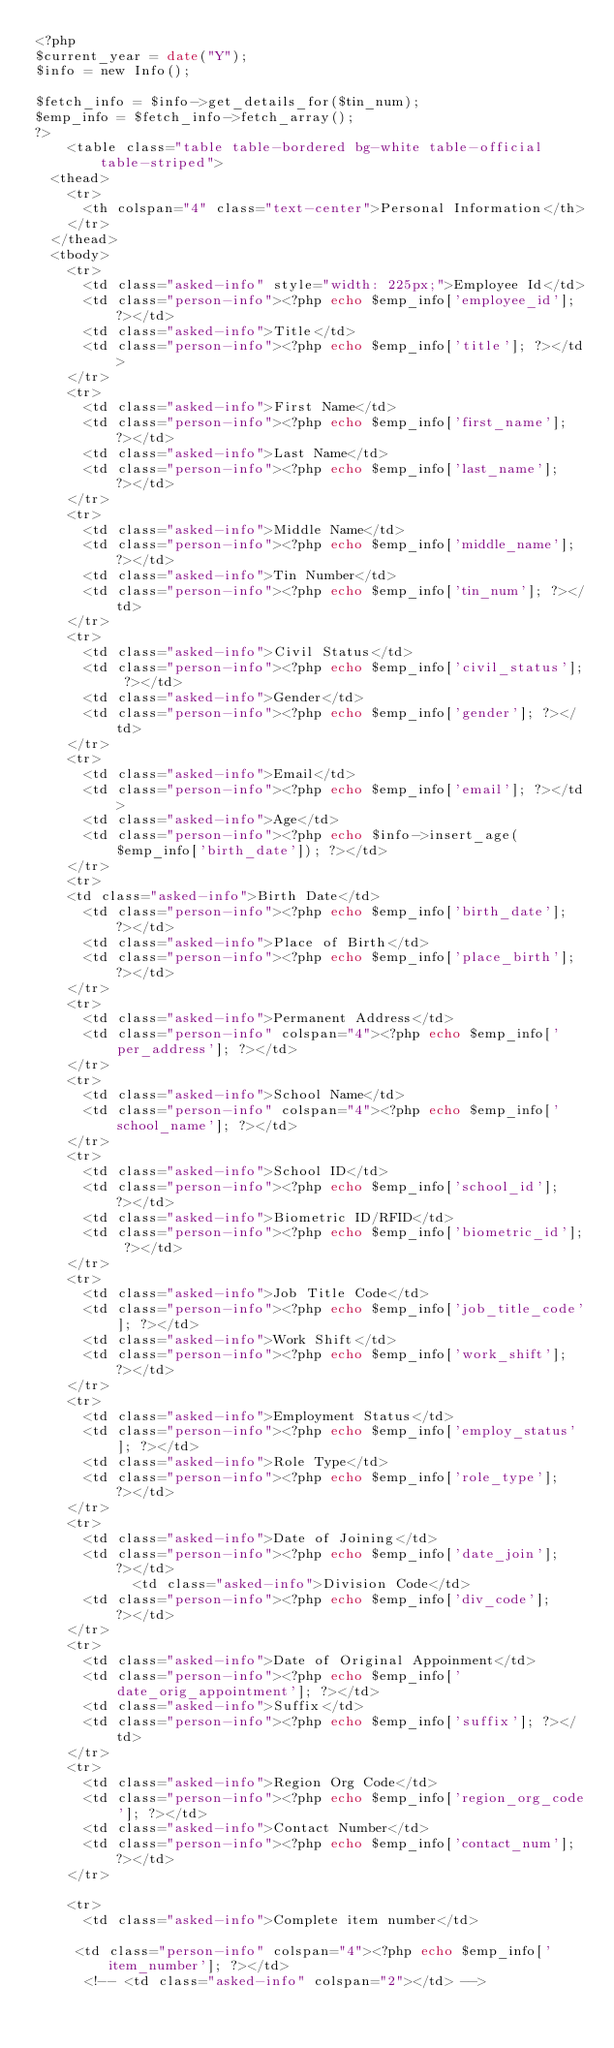<code> <loc_0><loc_0><loc_500><loc_500><_PHP_><?php
$current_year = date("Y");
$info = new Info();

$fetch_info = $info->get_details_for($tin_num);
$emp_info = $fetch_info->fetch_array();
?>
    <table class="table table-bordered bg-white table-official table-striped">
  <thead>
    <tr>
      <th colspan="4" class="text-center">Personal Information</th>
    </tr>
  </thead>
  <tbody>
    <tr>
      <td class="asked-info" style="width: 225px;">Employee Id</td>
      <td class="person-info"><?php echo $emp_info['employee_id']; ?></td>
      <td class="asked-info">Title</td>
      <td class="person-info"><?php echo $emp_info['title']; ?></td>
    </tr>
    <tr>
      <td class="asked-info">First Name</td>
      <td class="person-info"><?php echo $emp_info['first_name']; ?></td>
      <td class="asked-info">Last Name</td>
      <td class="person-info"><?php echo $emp_info['last_name']; ?></td>
    </tr>
    <tr>
      <td class="asked-info">Middle Name</td>
      <td class="person-info"><?php echo $emp_info['middle_name']; ?></td>
      <td class="asked-info">Tin Number</td>
      <td class="person-info"><?php echo $emp_info['tin_num']; ?></td>  
    </tr>
    <tr>
      <td class="asked-info">Civil Status</td>
      <td class="person-info"><?php echo $emp_info['civil_status']; ?></td>
      <td class="asked-info">Gender</td>
      <td class="person-info"><?php echo $emp_info['gender']; ?></td>
    </tr>
    <tr>  
      <td class="asked-info">Email</td>
      <td class="person-info"><?php echo $emp_info['email']; ?></td> 
      <td class="asked-info">Age</td>
      <td class="person-info"><?php echo $info->insert_age($emp_info['birth_date']); ?></td>   
    </tr>                          
    <tr>
    <td class="asked-info">Birth Date</td>
      <td class="person-info"><?php echo $emp_info['birth_date']; ?></td>
      <td class="asked-info">Place of Birth</td>
      <td class="person-info"><?php echo $emp_info['place_birth']; ?></td>   
    </tr>
    <tr>
      <td class="asked-info">Permanent Address</td>
      <td class="person-info" colspan="4"><?php echo $emp_info['per_address']; ?></td>    
    </tr>   
    <tr>
      <td class="asked-info">School Name</td>
      <td class="person-info" colspan="4"><?php echo $emp_info['school_name']; ?></td>    
    </tr>        
    <tr>
      <td class="asked-info">School ID</td>
      <td class="person-info"><?php echo $emp_info['school_id']; ?></td> 
      <td class="asked-info">Biometric ID/RFID</td>
      <td class="person-info"><?php echo $emp_info['biometric_id']; ?></td> 
    </tr>                          
    <tr>
      <td class="asked-info">Job Title Code</td>
      <td class="person-info"><?php echo $emp_info['job_title_code']; ?></td>
      <td class="asked-info">Work Shift</td>
      <td class="person-info"><?php echo $emp_info['work_shift']; ?></td>    
    </tr>
    <tr>
      <td class="asked-info">Employment Status</td>
      <td class="person-info"><?php echo $emp_info['employ_status']; ?></td>
      <td class="asked-info">Role Type</td>
      <td class="person-info"><?php echo $emp_info['role_type']; ?></td>
    </tr>                          
    <tr>
      <td class="asked-info">Date of Joining</td>
      <td class="person-info"><?php echo $emp_info['date_join']; ?></td>
            <td class="asked-info">Division Code</td>
      <td class="person-info"><?php echo $emp_info['div_code']; ?></td>
    </tr>                           
    <tr>
      <td class="asked-info">Date of Original Appoinment</td>
      <td class="person-info"><?php echo $emp_info['date_orig_appointment']; ?></td>
      <td class="asked-info">Suffix</td>
      <td class="person-info"><?php echo $emp_info['suffix']; ?></td>   
    </tr>                          
    <tr>
      <td class="asked-info">Region Org Code</td>
      <td class="person-info"><?php echo $emp_info['region_org_code']; ?></td>
      <td class="asked-info">Contact Number</td>
      <td class="person-info"><?php echo $emp_info['contact_num']; ?></td>    
    </tr>

    <tr>
      <td class="asked-info">Complete item number</td>
 
     <td class="person-info" colspan="4"><?php echo $emp_info['item_number']; ?></td>
      <!-- <td class="asked-info" colspan="2"></td> --></code> 